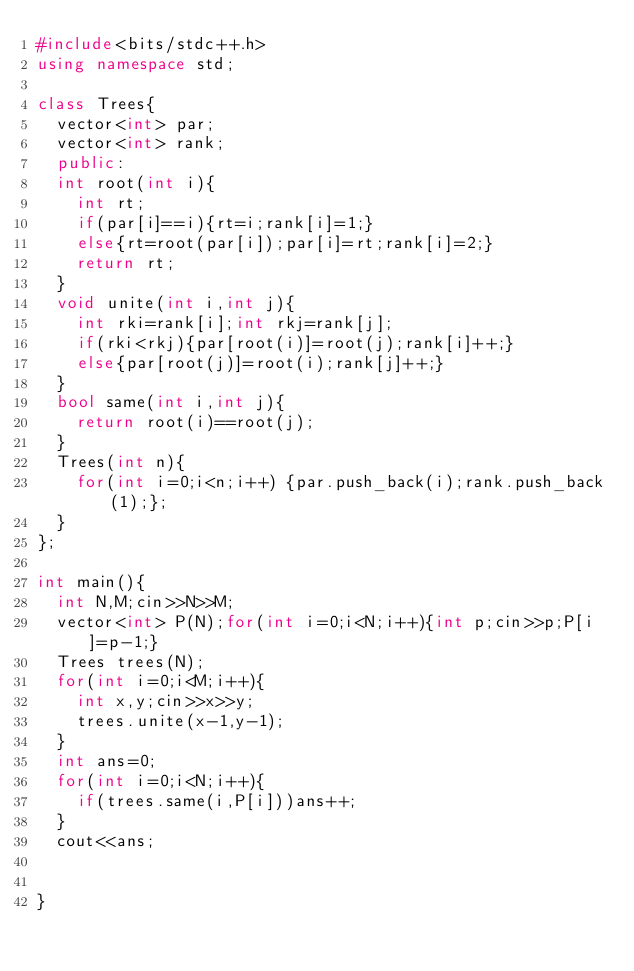Convert code to text. <code><loc_0><loc_0><loc_500><loc_500><_C++_>#include<bits/stdc++.h>
using namespace std;

class Trees{
  vector<int> par;
  vector<int> rank;
  public:
  int root(int i){
    int rt;
    if(par[i]==i){rt=i;rank[i]=1;}
    else{rt=root(par[i]);par[i]=rt;rank[i]=2;}
    return rt;
  }
  void unite(int i,int j){
    int rki=rank[i];int rkj=rank[j];
    if(rki<rkj){par[root(i)]=root(j);rank[i]++;}
    else{par[root(j)]=root(i);rank[j]++;}
  }
  bool same(int i,int j){
    return root(i)==root(j);
  }
  Trees(int n){
    for(int i=0;i<n;i++) {par.push_back(i);rank.push_back(1);};
  }
};

int main(){
  int N,M;cin>>N>>M;
  vector<int> P(N);for(int i=0;i<N;i++){int p;cin>>p;P[i]=p-1;}
  Trees trees(N);
  for(int i=0;i<M;i++){
    int x,y;cin>>x>>y;
    trees.unite(x-1,y-1);
  }
  int ans=0; 
  for(int i=0;i<N;i++){
    if(trees.same(i,P[i]))ans++;
  }
  cout<<ans;
  
  
}</code> 